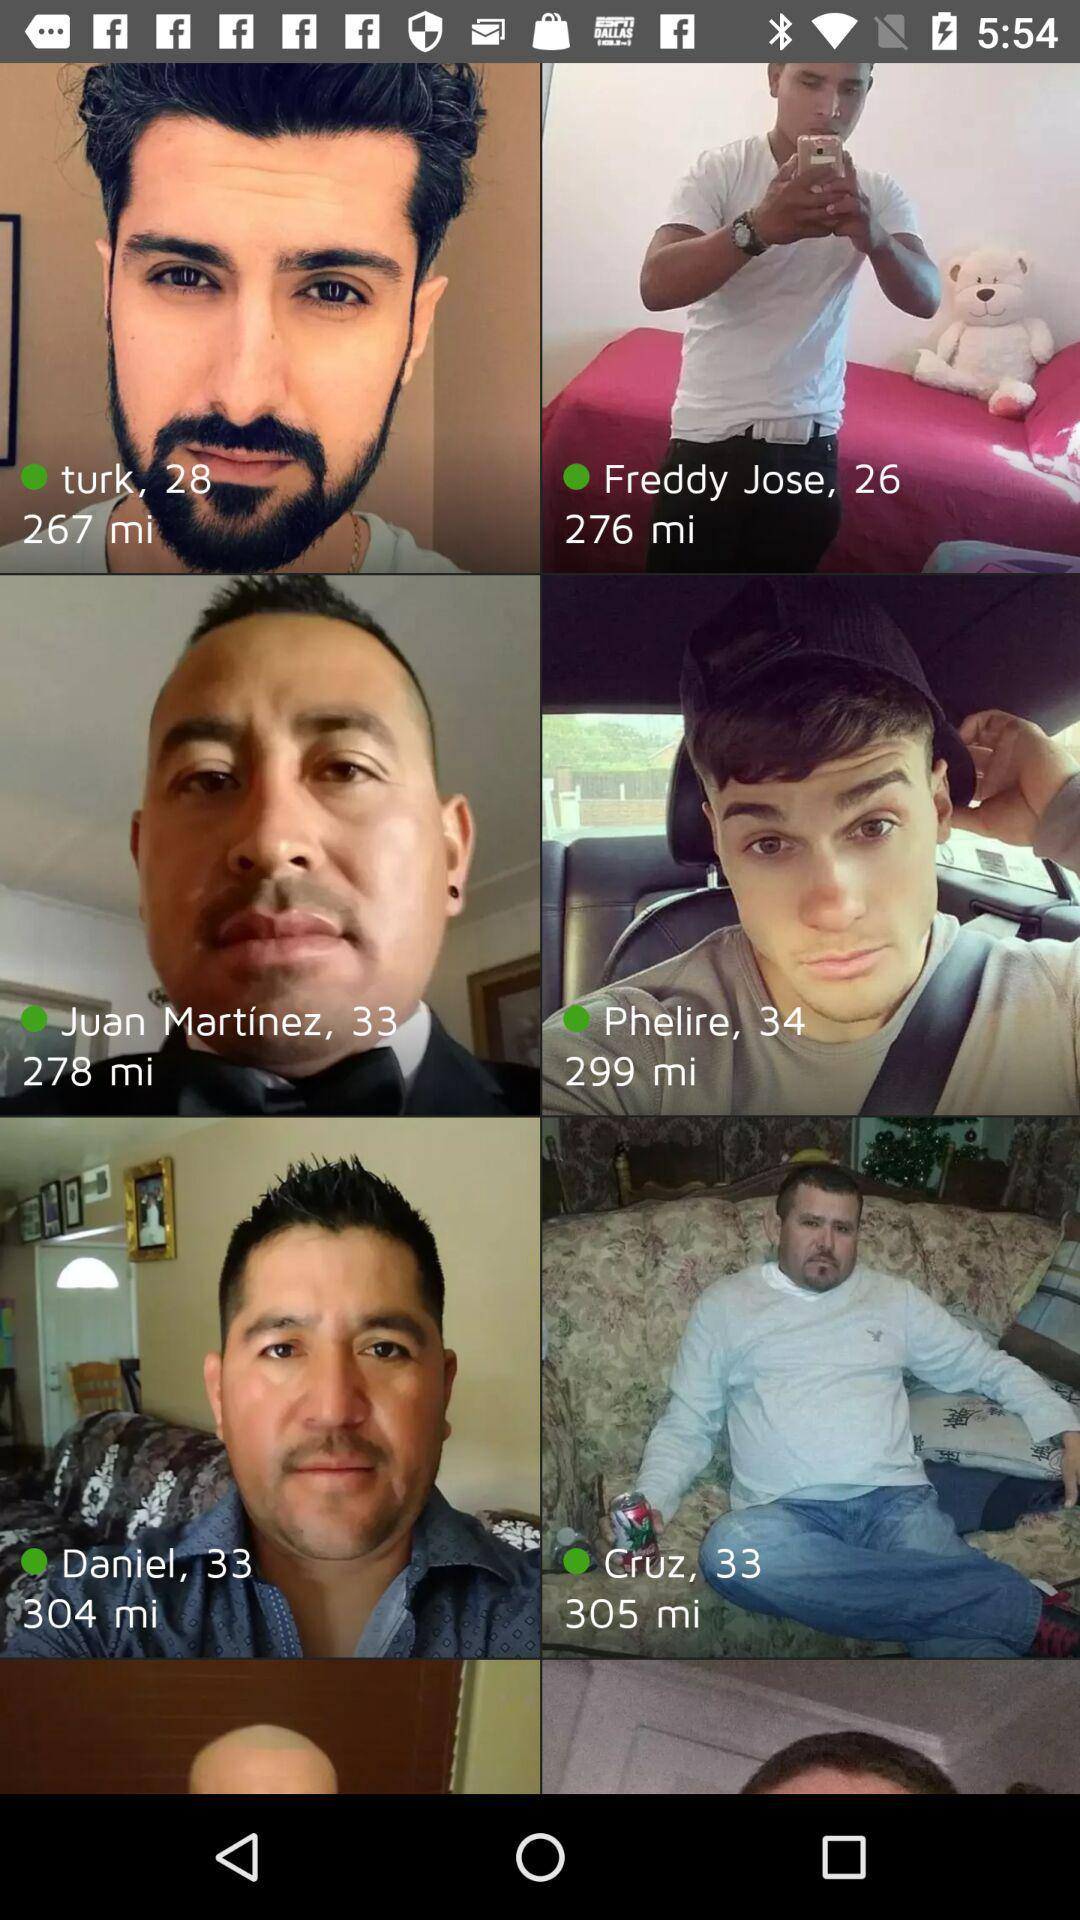How many years old is Phelire? Phelire is 34 years old. 